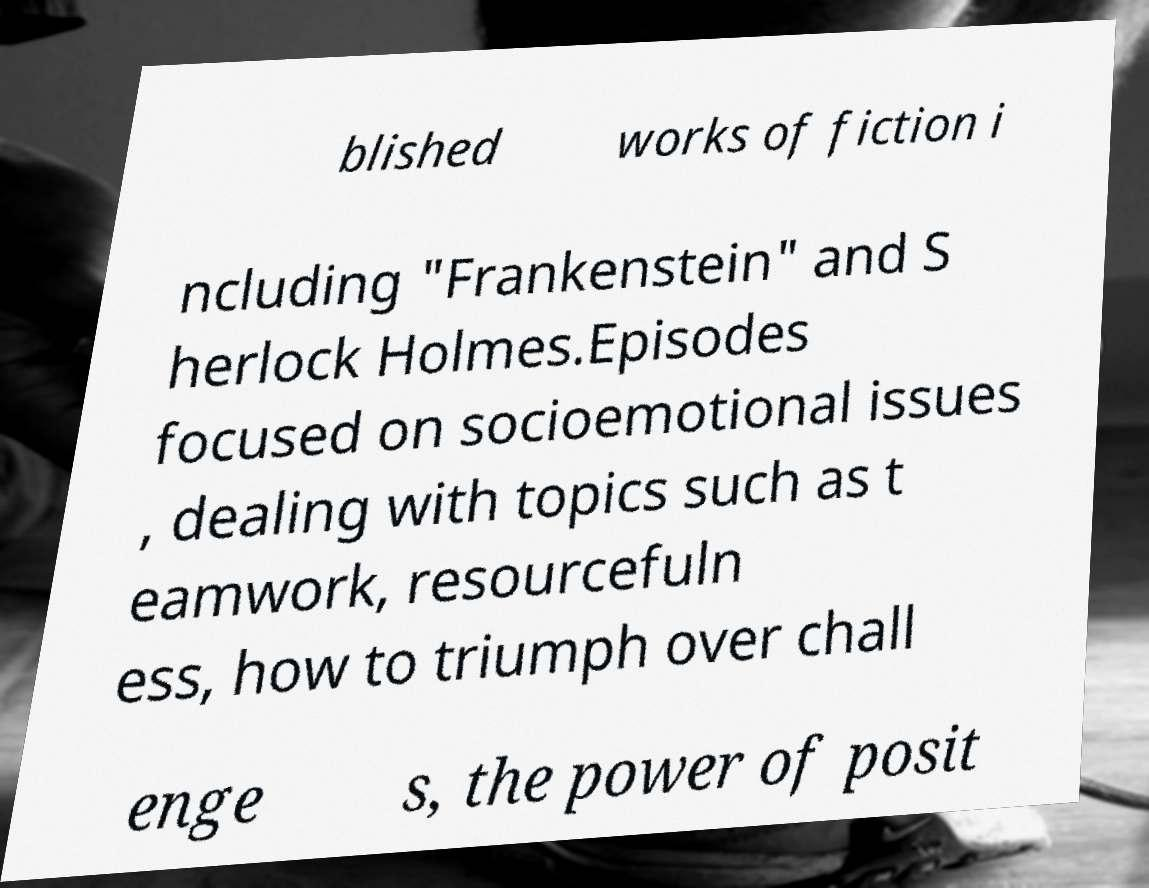What messages or text are displayed in this image? I need them in a readable, typed format. blished works of fiction i ncluding "Frankenstein" and S herlock Holmes.Episodes focused on socioemotional issues , dealing with topics such as t eamwork, resourcefuln ess, how to triumph over chall enge s, the power of posit 